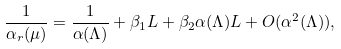Convert formula to latex. <formula><loc_0><loc_0><loc_500><loc_500>\frac { 1 } { \alpha _ { r } ( \mu ) } = \frac { 1 } { \alpha ( \Lambda ) } + \beta _ { 1 } L + \beta _ { 2 } \alpha ( \Lambda ) L + O ( \alpha ^ { 2 } ( \Lambda ) ) ,</formula> 